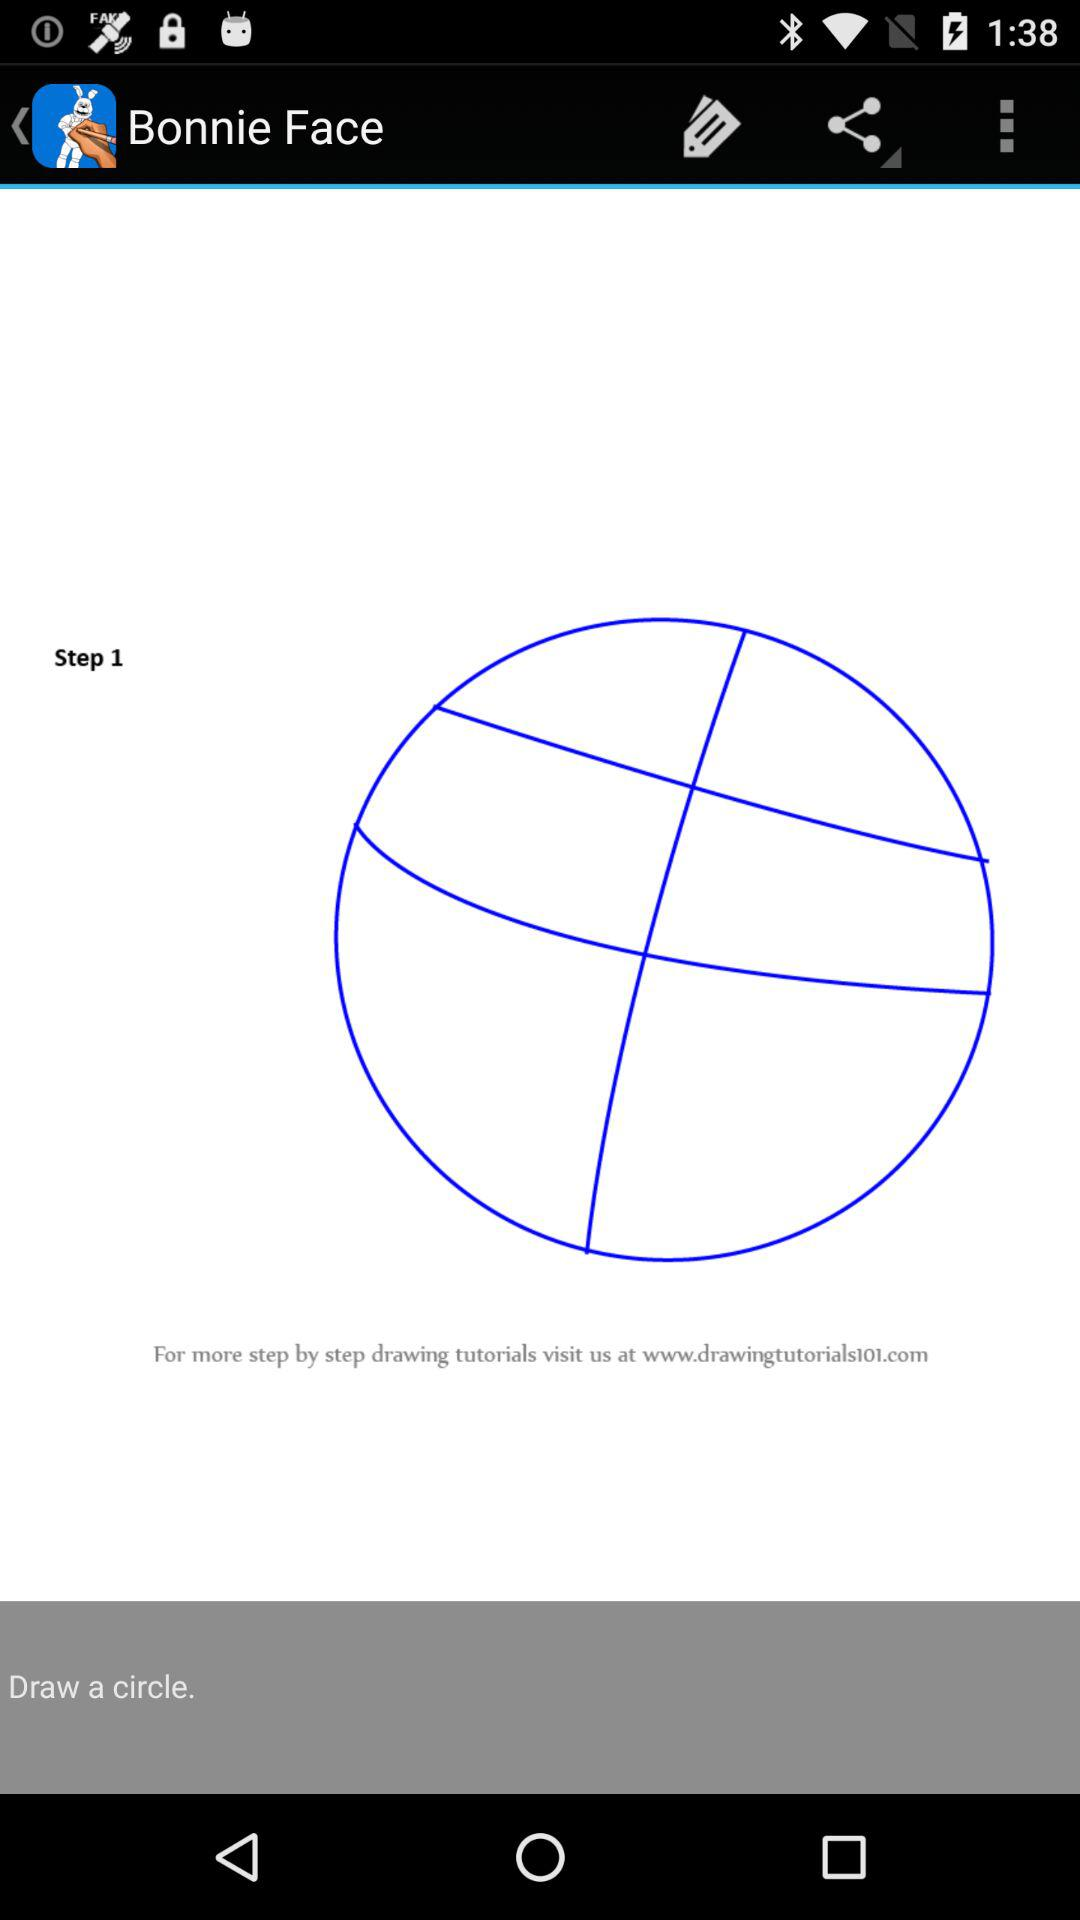How many steps are there in this drawing tutorial?
Answer the question using a single word or phrase. 1 